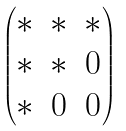<formula> <loc_0><loc_0><loc_500><loc_500>\begin{pmatrix} \ast & \ast & \ast \\ \ast & \ast & 0 \\ \ast & 0 & 0 \end{pmatrix}</formula> 